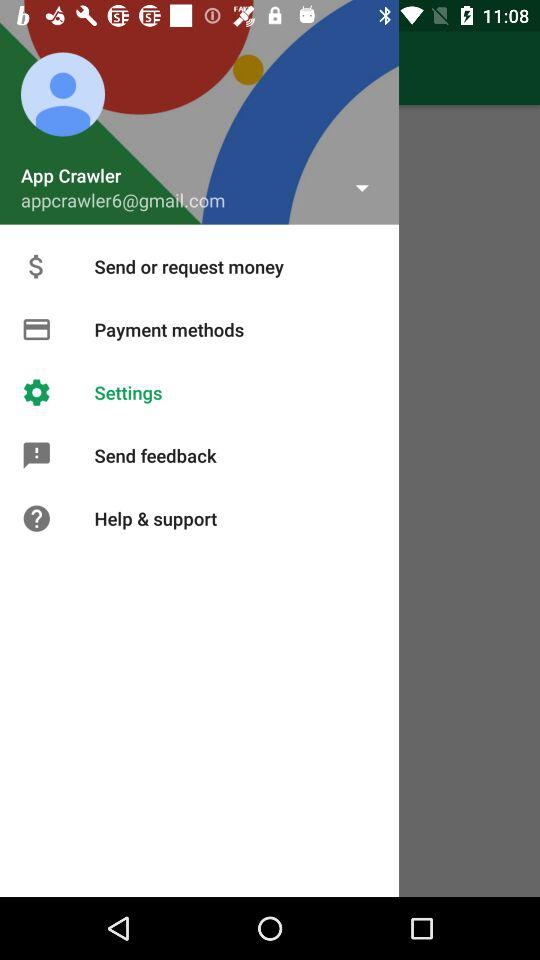What is the name of the user? The name of the user is App Crawler. 